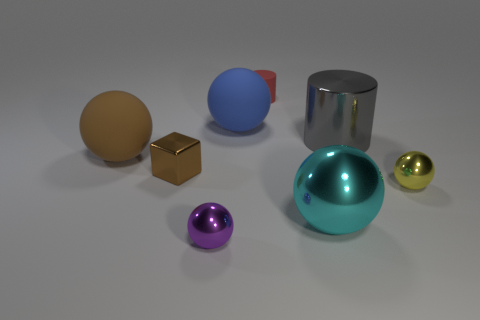There is a big metallic cylinder; is it the same color as the big ball right of the tiny rubber object?
Your response must be concise. No. How many tiny metal balls are to the right of the small yellow sphere?
Provide a succinct answer. 0. Are there fewer tiny purple shiny spheres that are to the left of the purple shiny sphere than shiny cylinders?
Provide a succinct answer. Yes. The tiny rubber object has what color?
Ensure brevity in your answer.  Red. Is the color of the large metallic thing behind the small yellow metallic sphere the same as the small block?
Your answer should be compact. No. The other small metallic object that is the same shape as the purple thing is what color?
Your answer should be very brief. Yellow. What number of large objects are blue balls or metallic spheres?
Provide a short and direct response. 2. There is a brown thing that is behind the tiny brown metal block; what is its size?
Make the answer very short. Large. Are there any large matte things of the same color as the block?
Offer a very short reply. Yes. Is the large metallic cylinder the same color as the small cylinder?
Offer a terse response. No. 